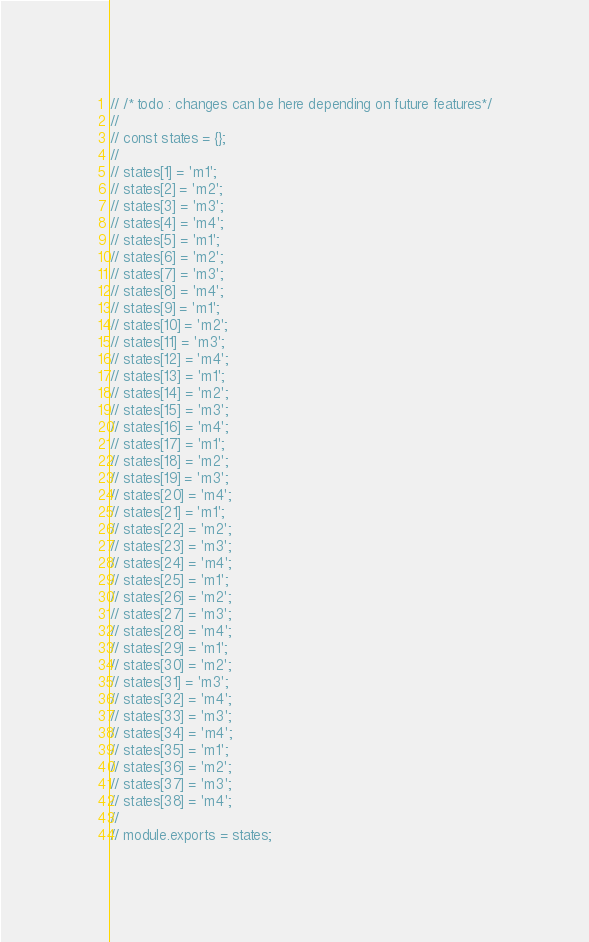Convert code to text. <code><loc_0><loc_0><loc_500><loc_500><_JavaScript_>// /* todo : changes can be here depending on future features*/
//
// const states = {};
//
// states[1] = 'm1';
// states[2] = 'm2';
// states[3] = 'm3';
// states[4] = 'm4';
// states[5] = 'm1';
// states[6] = 'm2';
// states[7] = 'm3';
// states[8] = 'm4';
// states[9] = 'm1';
// states[10] = 'm2';
// states[11] = 'm3';
// states[12] = 'm4';
// states[13] = 'm1';
// states[14] = 'm2';
// states[15] = 'm3';
// states[16] = 'm4';
// states[17] = 'm1';
// states[18] = 'm2';
// states[19] = 'm3';
// states[20] = 'm4';
// states[21] = 'm1';
// states[22] = 'm2';
// states[23] = 'm3';
// states[24] = 'm4';
// states[25] = 'm1';
// states[26] = 'm2';
// states[27] = 'm3';
// states[28] = 'm4';
// states[29] = 'm1';
// states[30] = 'm2';
// states[31] = 'm3';
// states[32] = 'm4';
// states[33] = 'm3';
// states[34] = 'm4';
// states[35] = 'm1';
// states[36] = 'm2';
// states[37] = 'm3';
// states[38] = 'm4';
//
// module.exports = states;
</code> 